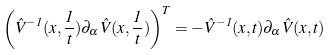<formula> <loc_0><loc_0><loc_500><loc_500>\left ( \hat { V } ^ { - 1 } ( x , { \frac { 1 } { t } } ) \partial _ { \alpha } \hat { V } ( x , { \frac { 1 } { t } } ) \right ) ^ { T } = - \hat { V } ^ { - 1 } ( x , t ) \partial _ { \alpha } \hat { V } ( x , t )</formula> 